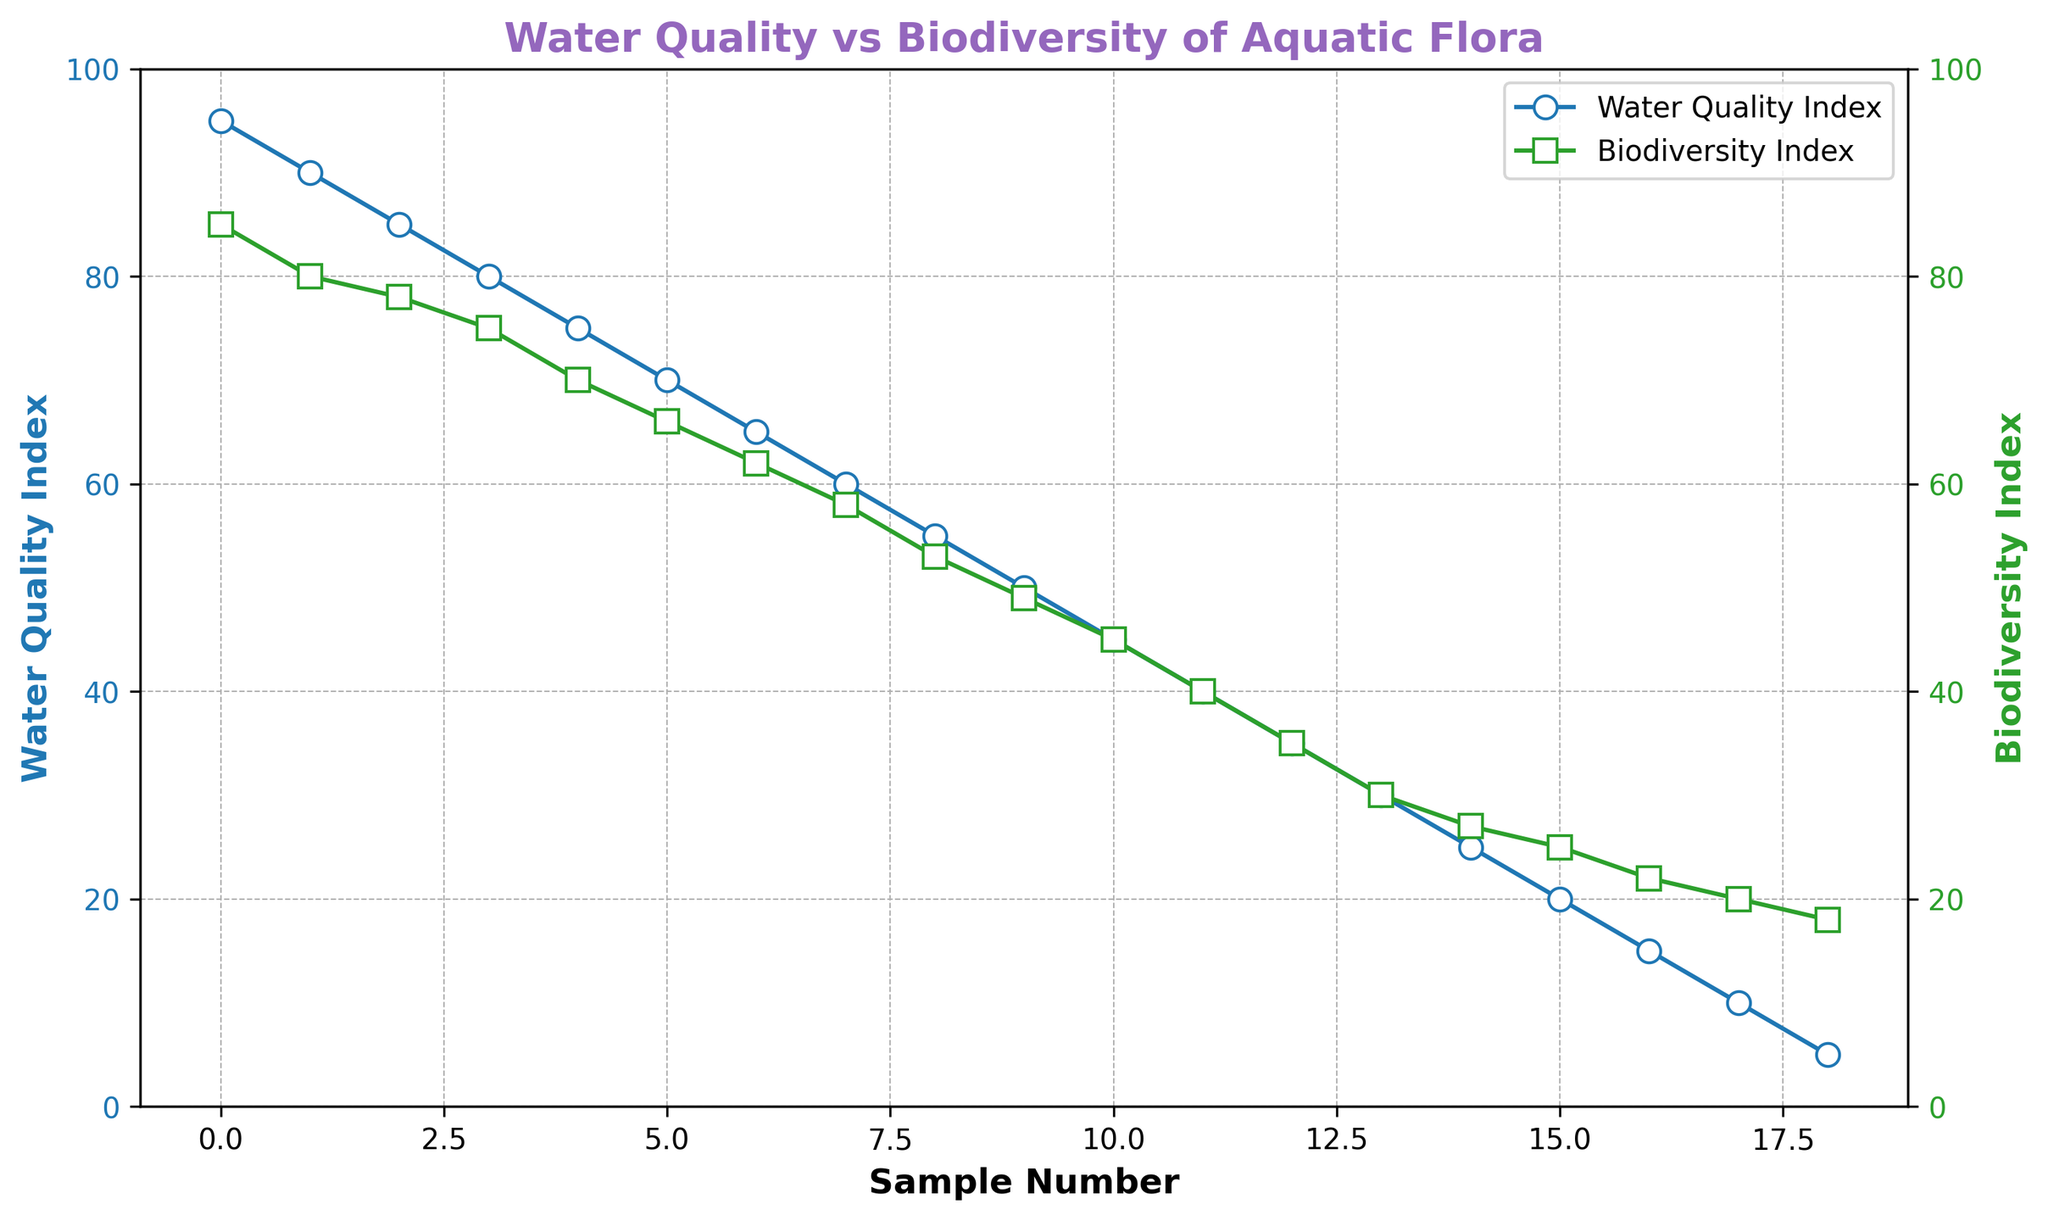What's the average of the Water Quality Index for all samples? There are 19 samples. To find the average, sum all the Water Quality Index values and divide by 19: (95 + 90 + 85 + 80 + 75 + 70 + 65 + 60 + 55 + 50 + 45 + 40 + 35 + 30 + 25 + 20 + 15 + 10 + 5) = 1000. So, the average is 1000 / 19 ≈ 52.63.
Answer: ≈ 52.63 When the Water Quality Index is 60, what is the corresponding Biodiversity Index? Locate the point on the Water Quality Index line where the value is 60, then check the corresponding value on the Biodiversity Index line. The Biodiversity Index is 58 when the Water Quality Index is 60.
Answer: 58 As the Water Quality Index decreases from 95 to 5, how does the Biodiversity Index change? Both the Water Quality Index and Biodiversity Index lines generally decrease, but Biodiversity Index decreases at a slower rate. It starts at 85 when Water Quality Index is 95 and ends at 18 when Water Quality Index is 5.
Answer: Decreases steadily Which index has more variability in its data points: Water Quality Index or Biodiversity Index? Compare the range (difference between maximum and minimum value) of each index. The range for Water Quality Index is 95 - 5 = 90, and for Biodiversity Index is 85 - 18 = 67. Water Quality Index has a larger range and thus more variability.
Answer: Water Quality Index At which point do the Water Quality Index and Biodiversity Index have the smallest difference? Calculate the absolute difference between the two indices at each sample and find the smallest difference. The smallest difference (8 points) occurs at the Water Quality Index of 60 where Biodiversity Index is 58.
Answer: Sample with Water Quality Index 60 What is the trend of Biodiversity Index as Water Quality Index approaches zero? Observe the Biodiversity Index line as the Water Quality Index line approaches the leftmost part of the plot (close to zero). The Biodiversity Index continues to decrease and stabilizes around 18.
Answer: Decreases and stabilizes Does the Biodiversity Index ever increase as the Water Quality Index decreases? Analyze the Biodiversity Index line as the Water Quality Index line decreases from 95 to 5. The Biodiversity Index generally decreases continuously, so it does not increase as Water Quality Index decreases.
Answer: No What is the color of the line representing the Biodiversity Index? The line representing the Biodiversity Index is visually distinguished by its color. The Biodiversity Index line is green.
Answer: Green Compare the slopes of the Water Quality Index and Biodiversity Index lines in the range of 75 to 55. Which one has a steeper decline? Observe the steepness of each line in the specified range. The Water Quality Index line declines from 75 to 55, while the Biodiversity Index declines from 70 to 53. Since both decrease by 20 and 17 respectively, the Water Quality Index has a steeper decline.
Answer: Water Quality Index At which sample number is the Biodiversity Index at its second-highest value, and what is that value? Identify the highest value of Biodiversity Index, which is 85 for the first sample. The second-highest value can be checked sequentially. The second-highest value is 80, which occurs at the second sample.
Answer: Second sample, 80 